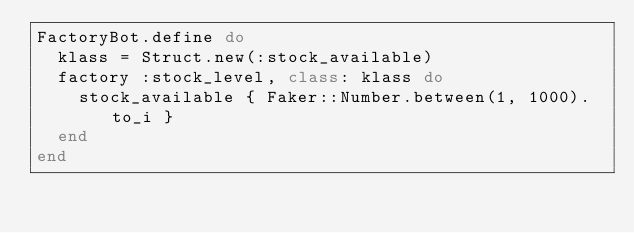Convert code to text. <code><loc_0><loc_0><loc_500><loc_500><_Ruby_>FactoryBot.define do
  klass = Struct.new(:stock_available)
  factory :stock_level, class: klass do
    stock_available { Faker::Number.between(1, 1000).to_i }
  end
end
</code> 